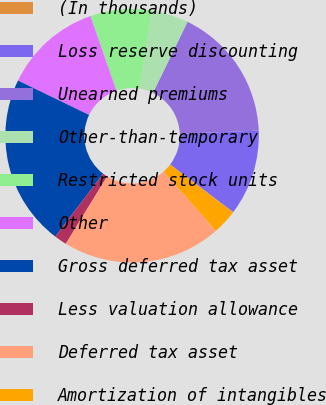Convert chart to OTSL. <chart><loc_0><loc_0><loc_500><loc_500><pie_chart><fcel>(In thousands)<fcel>Loss reserve discounting<fcel>Unearned premiums<fcel>Other-than-temporary<fcel>Restricted stock units<fcel>Other<fcel>Gross deferred tax asset<fcel>Less valuation allowance<fcel>Deferred tax asset<fcel>Amortization of intangibles<nl><fcel>0.05%<fcel>10.93%<fcel>17.15%<fcel>4.72%<fcel>7.82%<fcel>12.49%<fcel>21.81%<fcel>1.61%<fcel>20.26%<fcel>3.16%<nl></chart> 